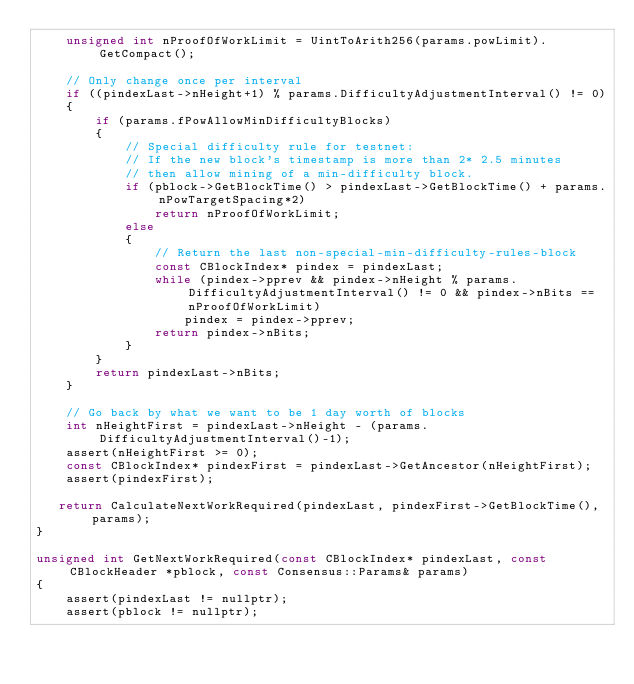<code> <loc_0><loc_0><loc_500><loc_500><_C++_>    unsigned int nProofOfWorkLimit = UintToArith256(params.powLimit).GetCompact();

    // Only change once per interval
    if ((pindexLast->nHeight+1) % params.DifficultyAdjustmentInterval() != 0)
    {
        if (params.fPowAllowMinDifficultyBlocks)
        {
            // Special difficulty rule for testnet:
            // If the new block's timestamp is more than 2* 2.5 minutes
            // then allow mining of a min-difficulty block.
            if (pblock->GetBlockTime() > pindexLast->GetBlockTime() + params.nPowTargetSpacing*2)
                return nProofOfWorkLimit;
            else
            {
                // Return the last non-special-min-difficulty-rules-block
                const CBlockIndex* pindex = pindexLast;
                while (pindex->pprev && pindex->nHeight % params.DifficultyAdjustmentInterval() != 0 && pindex->nBits == nProofOfWorkLimit)
                    pindex = pindex->pprev;
                return pindex->nBits;
            }
        }
        return pindexLast->nBits;
    }

    // Go back by what we want to be 1 day worth of blocks
    int nHeightFirst = pindexLast->nHeight - (params.DifficultyAdjustmentInterval()-1);
    assert(nHeightFirst >= 0);
    const CBlockIndex* pindexFirst = pindexLast->GetAncestor(nHeightFirst);
    assert(pindexFirst);

   return CalculateNextWorkRequired(pindexLast, pindexFirst->GetBlockTime(), params);
}

unsigned int GetNextWorkRequired(const CBlockIndex* pindexLast, const CBlockHeader *pblock, const Consensus::Params& params)
{
    assert(pindexLast != nullptr);
    assert(pblock != nullptr);</code> 